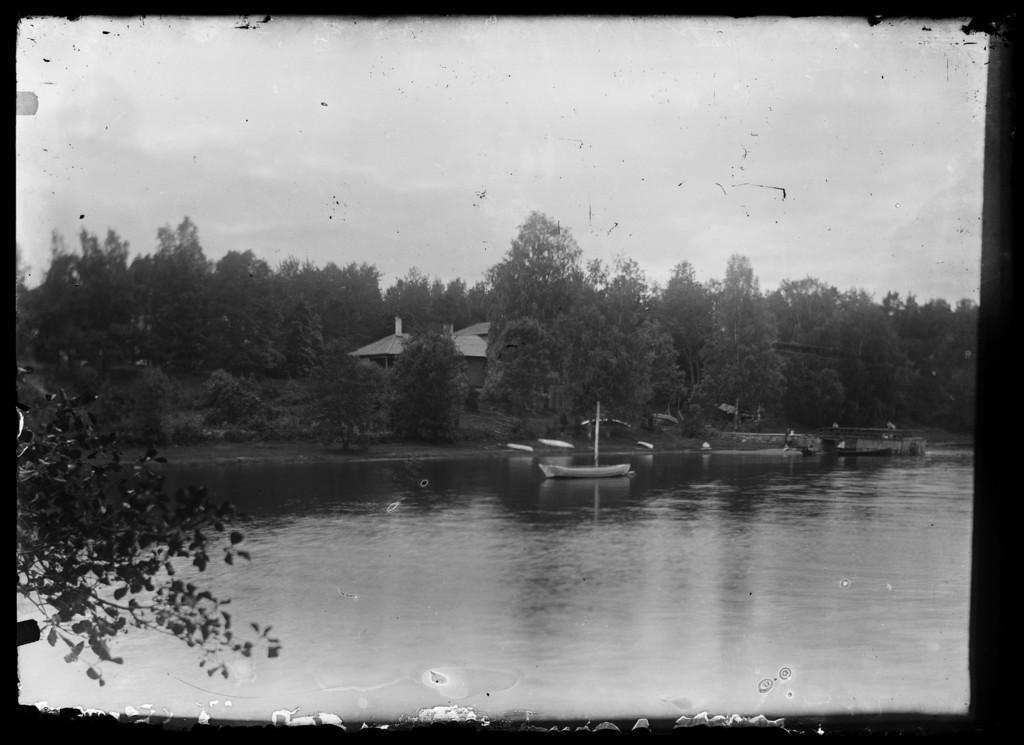How would you summarize this image in a sentence or two? This is a black and white image, we can see there is a boat on the surface of water is at the bottom of this image. There are some trees and a house in the background. There is a sky at the top of this image. 